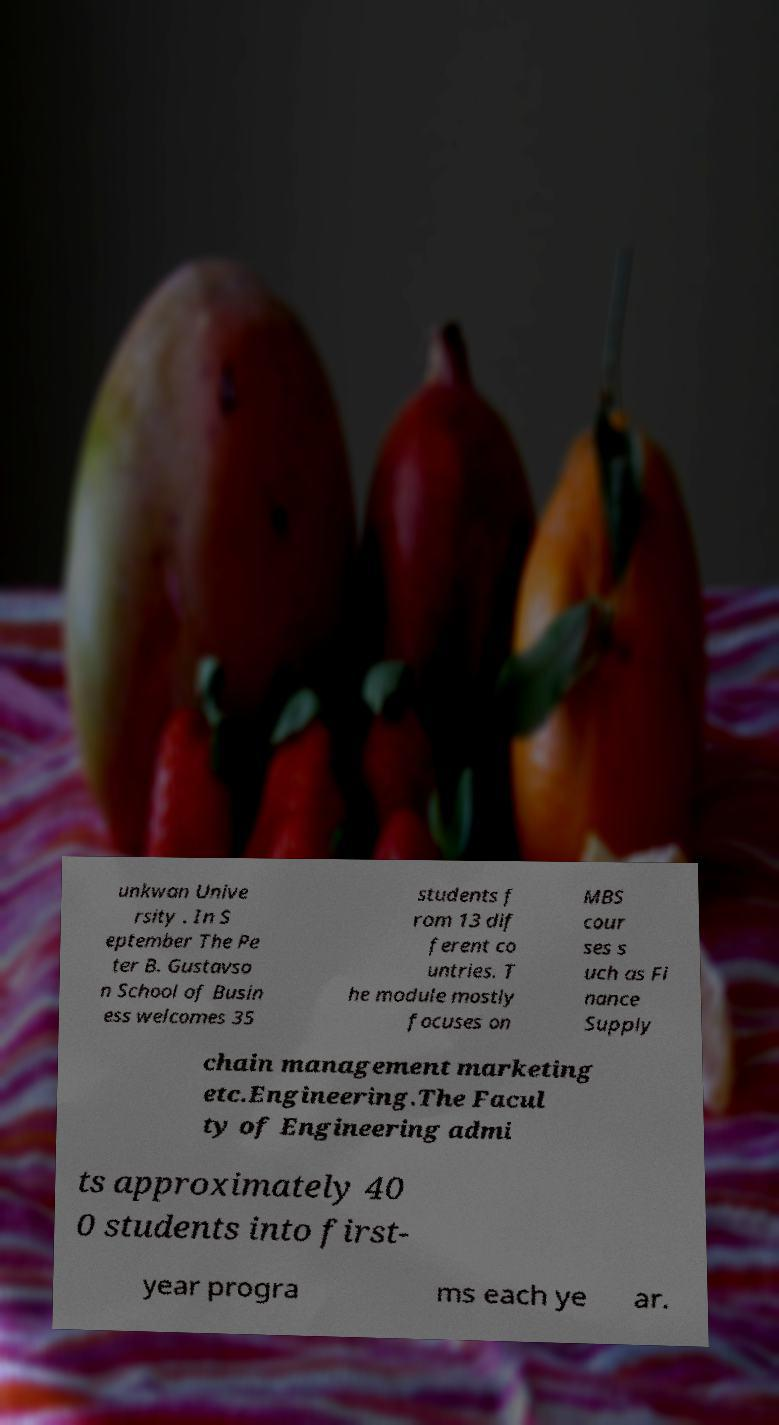Please read and relay the text visible in this image. What does it say? unkwan Unive rsity . In S eptember The Pe ter B. Gustavso n School of Busin ess welcomes 35 students f rom 13 dif ferent co untries. T he module mostly focuses on MBS cour ses s uch as Fi nance Supply chain management marketing etc.Engineering.The Facul ty of Engineering admi ts approximately 40 0 students into first- year progra ms each ye ar. 